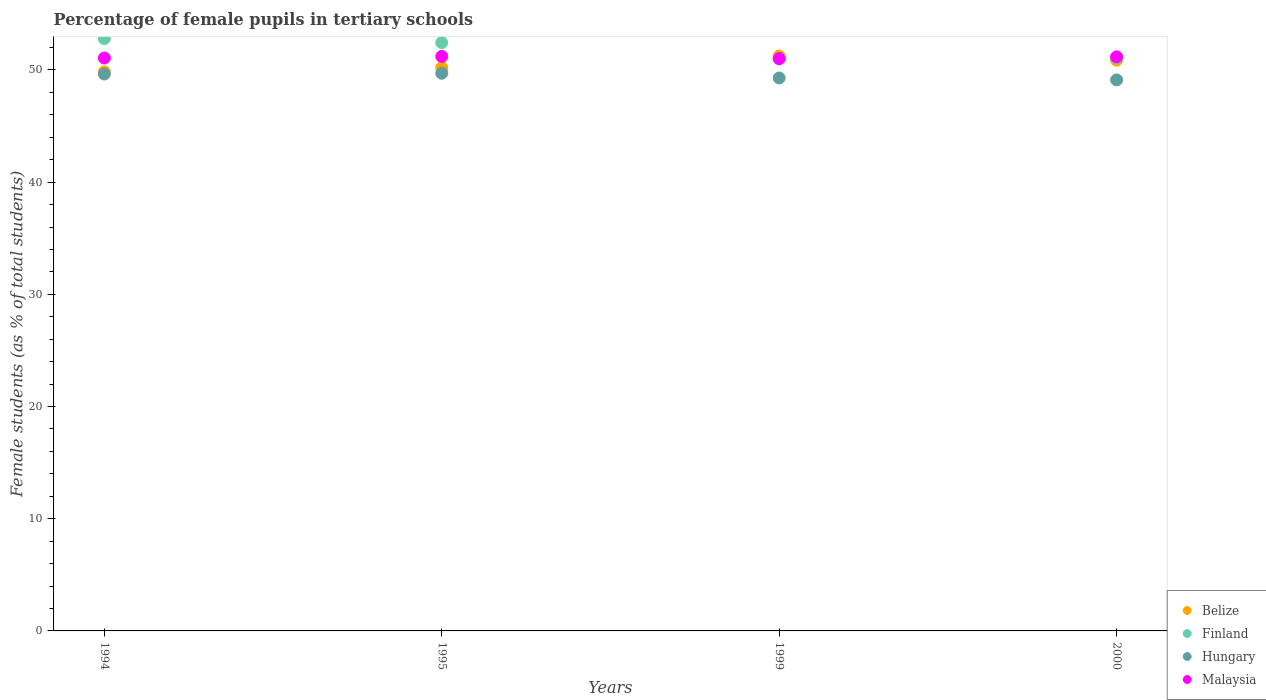How many different coloured dotlines are there?
Provide a short and direct response. 4. What is the percentage of female pupils in tertiary schools in Hungary in 1999?
Your answer should be very brief. 49.28. Across all years, what is the maximum percentage of female pupils in tertiary schools in Malaysia?
Give a very brief answer. 51.21. Across all years, what is the minimum percentage of female pupils in tertiary schools in Hungary?
Your answer should be compact. 49.11. What is the total percentage of female pupils in tertiary schools in Belize in the graph?
Your response must be concise. 202.14. What is the difference between the percentage of female pupils in tertiary schools in Malaysia in 1994 and that in 2000?
Your answer should be compact. -0.1. What is the difference between the percentage of female pupils in tertiary schools in Finland in 1995 and the percentage of female pupils in tertiary schools in Malaysia in 1999?
Your response must be concise. 1.43. What is the average percentage of female pupils in tertiary schools in Finland per year?
Give a very brief answer. 51.83. In the year 1994, what is the difference between the percentage of female pupils in tertiary schools in Hungary and percentage of female pupils in tertiary schools in Malaysia?
Provide a short and direct response. -1.43. In how many years, is the percentage of female pupils in tertiary schools in Malaysia greater than 34 %?
Keep it short and to the point. 4. What is the ratio of the percentage of female pupils in tertiary schools in Malaysia in 1995 to that in 2000?
Provide a succinct answer. 1. Is the percentage of female pupils in tertiary schools in Finland in 1994 less than that in 2000?
Your answer should be compact. No. Is the difference between the percentage of female pupils in tertiary schools in Hungary in 1994 and 2000 greater than the difference between the percentage of female pupils in tertiary schools in Malaysia in 1994 and 2000?
Keep it short and to the point. Yes. What is the difference between the highest and the second highest percentage of female pupils in tertiary schools in Malaysia?
Your answer should be very brief. 0.04. What is the difference between the highest and the lowest percentage of female pupils in tertiary schools in Malaysia?
Your response must be concise. 0.2. Is it the case that in every year, the sum of the percentage of female pupils in tertiary schools in Hungary and percentage of female pupils in tertiary schools in Malaysia  is greater than the sum of percentage of female pupils in tertiary schools in Finland and percentage of female pupils in tertiary schools in Belize?
Make the answer very short. No. Is it the case that in every year, the sum of the percentage of female pupils in tertiary schools in Malaysia and percentage of female pupils in tertiary schools in Belize  is greater than the percentage of female pupils in tertiary schools in Finland?
Your response must be concise. Yes. Is the percentage of female pupils in tertiary schools in Hungary strictly less than the percentage of female pupils in tertiary schools in Malaysia over the years?
Offer a very short reply. Yes. How many dotlines are there?
Make the answer very short. 4. What is the difference between two consecutive major ticks on the Y-axis?
Provide a succinct answer. 10. Does the graph contain any zero values?
Provide a short and direct response. No. Where does the legend appear in the graph?
Ensure brevity in your answer.  Bottom right. How are the legend labels stacked?
Provide a short and direct response. Vertical. What is the title of the graph?
Your answer should be compact. Percentage of female pupils in tertiary schools. What is the label or title of the X-axis?
Your answer should be very brief. Years. What is the label or title of the Y-axis?
Your response must be concise. Female students (as % of total students). What is the Female students (as % of total students) in Belize in 1994?
Ensure brevity in your answer.  49.83. What is the Female students (as % of total students) in Finland in 1994?
Offer a very short reply. 52.79. What is the Female students (as % of total students) in Hungary in 1994?
Provide a succinct answer. 49.63. What is the Female students (as % of total students) of Malaysia in 1994?
Offer a terse response. 51.06. What is the Female students (as % of total students) in Belize in 1995?
Give a very brief answer. 50.21. What is the Female students (as % of total students) in Finland in 1995?
Provide a short and direct response. 52.43. What is the Female students (as % of total students) in Hungary in 1995?
Your answer should be compact. 49.7. What is the Female students (as % of total students) in Malaysia in 1995?
Offer a very short reply. 51.21. What is the Female students (as % of total students) in Belize in 1999?
Ensure brevity in your answer.  51.24. What is the Female students (as % of total students) in Finland in 1999?
Keep it short and to the point. 51.02. What is the Female students (as % of total students) in Hungary in 1999?
Provide a succinct answer. 49.28. What is the Female students (as % of total students) of Malaysia in 1999?
Provide a short and direct response. 51. What is the Female students (as % of total students) of Belize in 2000?
Make the answer very short. 50.87. What is the Female students (as % of total students) of Finland in 2000?
Your answer should be compact. 51.08. What is the Female students (as % of total students) of Hungary in 2000?
Ensure brevity in your answer.  49.11. What is the Female students (as % of total students) of Malaysia in 2000?
Ensure brevity in your answer.  51.16. Across all years, what is the maximum Female students (as % of total students) in Belize?
Provide a short and direct response. 51.24. Across all years, what is the maximum Female students (as % of total students) in Finland?
Your answer should be very brief. 52.79. Across all years, what is the maximum Female students (as % of total students) of Hungary?
Offer a terse response. 49.7. Across all years, what is the maximum Female students (as % of total students) in Malaysia?
Offer a terse response. 51.21. Across all years, what is the minimum Female students (as % of total students) of Belize?
Give a very brief answer. 49.83. Across all years, what is the minimum Female students (as % of total students) in Finland?
Your answer should be very brief. 51.02. Across all years, what is the minimum Female students (as % of total students) in Hungary?
Keep it short and to the point. 49.11. Across all years, what is the minimum Female students (as % of total students) in Malaysia?
Ensure brevity in your answer.  51. What is the total Female students (as % of total students) of Belize in the graph?
Offer a very short reply. 202.14. What is the total Female students (as % of total students) in Finland in the graph?
Make the answer very short. 207.32. What is the total Female students (as % of total students) in Hungary in the graph?
Offer a terse response. 197.73. What is the total Female students (as % of total students) of Malaysia in the graph?
Provide a succinct answer. 204.44. What is the difference between the Female students (as % of total students) in Belize in 1994 and that in 1995?
Offer a very short reply. -0.38. What is the difference between the Female students (as % of total students) in Finland in 1994 and that in 1995?
Offer a terse response. 0.35. What is the difference between the Female students (as % of total students) of Hungary in 1994 and that in 1995?
Your response must be concise. -0.07. What is the difference between the Female students (as % of total students) in Malaysia in 1994 and that in 1995?
Give a very brief answer. -0.14. What is the difference between the Female students (as % of total students) in Belize in 1994 and that in 1999?
Your response must be concise. -1.41. What is the difference between the Female students (as % of total students) in Finland in 1994 and that in 1999?
Give a very brief answer. 1.77. What is the difference between the Female students (as % of total students) of Hungary in 1994 and that in 1999?
Keep it short and to the point. 0.35. What is the difference between the Female students (as % of total students) in Malaysia in 1994 and that in 1999?
Your answer should be very brief. 0.06. What is the difference between the Female students (as % of total students) in Belize in 1994 and that in 2000?
Make the answer very short. -1.05. What is the difference between the Female students (as % of total students) in Finland in 1994 and that in 2000?
Give a very brief answer. 1.71. What is the difference between the Female students (as % of total students) in Hungary in 1994 and that in 2000?
Give a very brief answer. 0.52. What is the difference between the Female students (as % of total students) of Malaysia in 1994 and that in 2000?
Ensure brevity in your answer.  -0.1. What is the difference between the Female students (as % of total students) in Belize in 1995 and that in 1999?
Give a very brief answer. -1.03. What is the difference between the Female students (as % of total students) in Finland in 1995 and that in 1999?
Provide a short and direct response. 1.42. What is the difference between the Female students (as % of total students) of Hungary in 1995 and that in 1999?
Your answer should be very brief. 0.42. What is the difference between the Female students (as % of total students) in Malaysia in 1995 and that in 1999?
Provide a succinct answer. 0.2. What is the difference between the Female students (as % of total students) of Belize in 1995 and that in 2000?
Ensure brevity in your answer.  -0.66. What is the difference between the Female students (as % of total students) of Finland in 1995 and that in 2000?
Offer a terse response. 1.36. What is the difference between the Female students (as % of total students) in Hungary in 1995 and that in 2000?
Give a very brief answer. 0.59. What is the difference between the Female students (as % of total students) in Malaysia in 1995 and that in 2000?
Provide a short and direct response. 0.04. What is the difference between the Female students (as % of total students) in Belize in 1999 and that in 2000?
Ensure brevity in your answer.  0.36. What is the difference between the Female students (as % of total students) in Finland in 1999 and that in 2000?
Your answer should be compact. -0.06. What is the difference between the Female students (as % of total students) of Hungary in 1999 and that in 2000?
Make the answer very short. 0.17. What is the difference between the Female students (as % of total students) in Malaysia in 1999 and that in 2000?
Your response must be concise. -0.16. What is the difference between the Female students (as % of total students) in Belize in 1994 and the Female students (as % of total students) in Finland in 1995?
Offer a terse response. -2.61. What is the difference between the Female students (as % of total students) in Belize in 1994 and the Female students (as % of total students) in Hungary in 1995?
Give a very brief answer. 0.12. What is the difference between the Female students (as % of total students) in Belize in 1994 and the Female students (as % of total students) in Malaysia in 1995?
Your answer should be compact. -1.38. What is the difference between the Female students (as % of total students) of Finland in 1994 and the Female students (as % of total students) of Hungary in 1995?
Ensure brevity in your answer.  3.08. What is the difference between the Female students (as % of total students) of Finland in 1994 and the Female students (as % of total students) of Malaysia in 1995?
Keep it short and to the point. 1.58. What is the difference between the Female students (as % of total students) of Hungary in 1994 and the Female students (as % of total students) of Malaysia in 1995?
Your answer should be compact. -1.57. What is the difference between the Female students (as % of total students) in Belize in 1994 and the Female students (as % of total students) in Finland in 1999?
Give a very brief answer. -1.19. What is the difference between the Female students (as % of total students) of Belize in 1994 and the Female students (as % of total students) of Hungary in 1999?
Your answer should be compact. 0.54. What is the difference between the Female students (as % of total students) of Belize in 1994 and the Female students (as % of total students) of Malaysia in 1999?
Provide a short and direct response. -1.18. What is the difference between the Female students (as % of total students) of Finland in 1994 and the Female students (as % of total students) of Hungary in 1999?
Ensure brevity in your answer.  3.51. What is the difference between the Female students (as % of total students) in Finland in 1994 and the Female students (as % of total students) in Malaysia in 1999?
Provide a succinct answer. 1.78. What is the difference between the Female students (as % of total students) in Hungary in 1994 and the Female students (as % of total students) in Malaysia in 1999?
Ensure brevity in your answer.  -1.37. What is the difference between the Female students (as % of total students) of Belize in 1994 and the Female students (as % of total students) of Finland in 2000?
Your answer should be compact. -1.25. What is the difference between the Female students (as % of total students) of Belize in 1994 and the Female students (as % of total students) of Hungary in 2000?
Ensure brevity in your answer.  0.71. What is the difference between the Female students (as % of total students) of Belize in 1994 and the Female students (as % of total students) of Malaysia in 2000?
Provide a succinct answer. -1.34. What is the difference between the Female students (as % of total students) in Finland in 1994 and the Female students (as % of total students) in Hungary in 2000?
Your response must be concise. 3.68. What is the difference between the Female students (as % of total students) of Finland in 1994 and the Female students (as % of total students) of Malaysia in 2000?
Your answer should be very brief. 1.62. What is the difference between the Female students (as % of total students) in Hungary in 1994 and the Female students (as % of total students) in Malaysia in 2000?
Provide a succinct answer. -1.53. What is the difference between the Female students (as % of total students) of Belize in 1995 and the Female students (as % of total students) of Finland in 1999?
Your answer should be very brief. -0.81. What is the difference between the Female students (as % of total students) in Belize in 1995 and the Female students (as % of total students) in Hungary in 1999?
Offer a very short reply. 0.93. What is the difference between the Female students (as % of total students) in Belize in 1995 and the Female students (as % of total students) in Malaysia in 1999?
Your response must be concise. -0.8. What is the difference between the Female students (as % of total students) in Finland in 1995 and the Female students (as % of total students) in Hungary in 1999?
Your answer should be very brief. 3.15. What is the difference between the Female students (as % of total students) of Finland in 1995 and the Female students (as % of total students) of Malaysia in 1999?
Provide a short and direct response. 1.43. What is the difference between the Female students (as % of total students) of Hungary in 1995 and the Female students (as % of total students) of Malaysia in 1999?
Offer a very short reply. -1.3. What is the difference between the Female students (as % of total students) of Belize in 1995 and the Female students (as % of total students) of Finland in 2000?
Your answer should be very brief. -0.87. What is the difference between the Female students (as % of total students) of Belize in 1995 and the Female students (as % of total students) of Hungary in 2000?
Keep it short and to the point. 1.1. What is the difference between the Female students (as % of total students) in Belize in 1995 and the Female students (as % of total students) in Malaysia in 2000?
Your response must be concise. -0.96. What is the difference between the Female students (as % of total students) of Finland in 1995 and the Female students (as % of total students) of Hungary in 2000?
Ensure brevity in your answer.  3.32. What is the difference between the Female students (as % of total students) of Finland in 1995 and the Female students (as % of total students) of Malaysia in 2000?
Your answer should be very brief. 1.27. What is the difference between the Female students (as % of total students) of Hungary in 1995 and the Female students (as % of total students) of Malaysia in 2000?
Ensure brevity in your answer.  -1.46. What is the difference between the Female students (as % of total students) of Belize in 1999 and the Female students (as % of total students) of Finland in 2000?
Give a very brief answer. 0.16. What is the difference between the Female students (as % of total students) of Belize in 1999 and the Female students (as % of total students) of Hungary in 2000?
Make the answer very short. 2.12. What is the difference between the Female students (as % of total students) of Belize in 1999 and the Female students (as % of total students) of Malaysia in 2000?
Offer a terse response. 0.07. What is the difference between the Female students (as % of total students) of Finland in 1999 and the Female students (as % of total students) of Hungary in 2000?
Keep it short and to the point. 1.91. What is the difference between the Female students (as % of total students) of Finland in 1999 and the Female students (as % of total students) of Malaysia in 2000?
Your answer should be very brief. -0.15. What is the difference between the Female students (as % of total students) of Hungary in 1999 and the Female students (as % of total students) of Malaysia in 2000?
Provide a succinct answer. -1.88. What is the average Female students (as % of total students) of Belize per year?
Give a very brief answer. 50.53. What is the average Female students (as % of total students) of Finland per year?
Your response must be concise. 51.83. What is the average Female students (as % of total students) in Hungary per year?
Ensure brevity in your answer.  49.43. What is the average Female students (as % of total students) in Malaysia per year?
Provide a succinct answer. 51.11. In the year 1994, what is the difference between the Female students (as % of total students) of Belize and Female students (as % of total students) of Finland?
Provide a short and direct response. -2.96. In the year 1994, what is the difference between the Female students (as % of total students) of Belize and Female students (as % of total students) of Hungary?
Offer a terse response. 0.19. In the year 1994, what is the difference between the Female students (as % of total students) in Belize and Female students (as % of total students) in Malaysia?
Offer a terse response. -1.24. In the year 1994, what is the difference between the Female students (as % of total students) of Finland and Female students (as % of total students) of Hungary?
Your answer should be compact. 3.15. In the year 1994, what is the difference between the Female students (as % of total students) in Finland and Female students (as % of total students) in Malaysia?
Offer a terse response. 1.73. In the year 1994, what is the difference between the Female students (as % of total students) in Hungary and Female students (as % of total students) in Malaysia?
Keep it short and to the point. -1.43. In the year 1995, what is the difference between the Female students (as % of total students) of Belize and Female students (as % of total students) of Finland?
Make the answer very short. -2.23. In the year 1995, what is the difference between the Female students (as % of total students) in Belize and Female students (as % of total students) in Hungary?
Your answer should be very brief. 0.5. In the year 1995, what is the difference between the Female students (as % of total students) in Belize and Female students (as % of total students) in Malaysia?
Your answer should be compact. -1. In the year 1995, what is the difference between the Female students (as % of total students) of Finland and Female students (as % of total students) of Hungary?
Ensure brevity in your answer.  2.73. In the year 1995, what is the difference between the Female students (as % of total students) of Finland and Female students (as % of total students) of Malaysia?
Keep it short and to the point. 1.23. In the year 1995, what is the difference between the Female students (as % of total students) of Hungary and Female students (as % of total students) of Malaysia?
Provide a succinct answer. -1.5. In the year 1999, what is the difference between the Female students (as % of total students) in Belize and Female students (as % of total students) in Finland?
Your response must be concise. 0.22. In the year 1999, what is the difference between the Female students (as % of total students) of Belize and Female students (as % of total students) of Hungary?
Keep it short and to the point. 1.95. In the year 1999, what is the difference between the Female students (as % of total students) in Belize and Female students (as % of total students) in Malaysia?
Provide a short and direct response. 0.23. In the year 1999, what is the difference between the Female students (as % of total students) of Finland and Female students (as % of total students) of Hungary?
Offer a very short reply. 1.74. In the year 1999, what is the difference between the Female students (as % of total students) in Finland and Female students (as % of total students) in Malaysia?
Keep it short and to the point. 0.01. In the year 1999, what is the difference between the Female students (as % of total students) in Hungary and Female students (as % of total students) in Malaysia?
Your response must be concise. -1.72. In the year 2000, what is the difference between the Female students (as % of total students) in Belize and Female students (as % of total students) in Finland?
Your answer should be very brief. -0.21. In the year 2000, what is the difference between the Female students (as % of total students) of Belize and Female students (as % of total students) of Hungary?
Offer a terse response. 1.76. In the year 2000, what is the difference between the Female students (as % of total students) in Belize and Female students (as % of total students) in Malaysia?
Offer a terse response. -0.29. In the year 2000, what is the difference between the Female students (as % of total students) in Finland and Female students (as % of total students) in Hungary?
Make the answer very short. 1.97. In the year 2000, what is the difference between the Female students (as % of total students) of Finland and Female students (as % of total students) of Malaysia?
Your response must be concise. -0.09. In the year 2000, what is the difference between the Female students (as % of total students) of Hungary and Female students (as % of total students) of Malaysia?
Your response must be concise. -2.05. What is the ratio of the Female students (as % of total students) in Belize in 1994 to that in 1995?
Offer a very short reply. 0.99. What is the ratio of the Female students (as % of total students) in Finland in 1994 to that in 1995?
Ensure brevity in your answer.  1.01. What is the ratio of the Female students (as % of total students) in Hungary in 1994 to that in 1995?
Offer a terse response. 1. What is the ratio of the Female students (as % of total students) of Malaysia in 1994 to that in 1995?
Provide a short and direct response. 1. What is the ratio of the Female students (as % of total students) in Belize in 1994 to that in 1999?
Give a very brief answer. 0.97. What is the ratio of the Female students (as % of total students) in Finland in 1994 to that in 1999?
Your response must be concise. 1.03. What is the ratio of the Female students (as % of total students) in Hungary in 1994 to that in 1999?
Your response must be concise. 1.01. What is the ratio of the Female students (as % of total students) in Belize in 1994 to that in 2000?
Provide a succinct answer. 0.98. What is the ratio of the Female students (as % of total students) in Finland in 1994 to that in 2000?
Offer a terse response. 1.03. What is the ratio of the Female students (as % of total students) of Hungary in 1994 to that in 2000?
Ensure brevity in your answer.  1.01. What is the ratio of the Female students (as % of total students) of Malaysia in 1994 to that in 2000?
Your answer should be very brief. 1. What is the ratio of the Female students (as % of total students) of Belize in 1995 to that in 1999?
Provide a succinct answer. 0.98. What is the ratio of the Female students (as % of total students) of Finland in 1995 to that in 1999?
Give a very brief answer. 1.03. What is the ratio of the Female students (as % of total students) of Hungary in 1995 to that in 1999?
Your response must be concise. 1.01. What is the ratio of the Female students (as % of total students) in Belize in 1995 to that in 2000?
Provide a short and direct response. 0.99. What is the ratio of the Female students (as % of total students) in Finland in 1995 to that in 2000?
Provide a succinct answer. 1.03. What is the ratio of the Female students (as % of total students) of Hungary in 1995 to that in 2000?
Provide a succinct answer. 1.01. What is the ratio of the Female students (as % of total students) in Belize in 1999 to that in 2000?
Provide a short and direct response. 1.01. What is the ratio of the Female students (as % of total students) in Finland in 1999 to that in 2000?
Offer a terse response. 1. What is the ratio of the Female students (as % of total students) of Hungary in 1999 to that in 2000?
Give a very brief answer. 1. What is the difference between the highest and the second highest Female students (as % of total students) in Belize?
Offer a very short reply. 0.36. What is the difference between the highest and the second highest Female students (as % of total students) in Finland?
Make the answer very short. 0.35. What is the difference between the highest and the second highest Female students (as % of total students) in Hungary?
Keep it short and to the point. 0.07. What is the difference between the highest and the second highest Female students (as % of total students) in Malaysia?
Keep it short and to the point. 0.04. What is the difference between the highest and the lowest Female students (as % of total students) in Belize?
Your answer should be very brief. 1.41. What is the difference between the highest and the lowest Female students (as % of total students) of Finland?
Offer a very short reply. 1.77. What is the difference between the highest and the lowest Female students (as % of total students) in Hungary?
Provide a succinct answer. 0.59. What is the difference between the highest and the lowest Female students (as % of total students) in Malaysia?
Give a very brief answer. 0.2. 